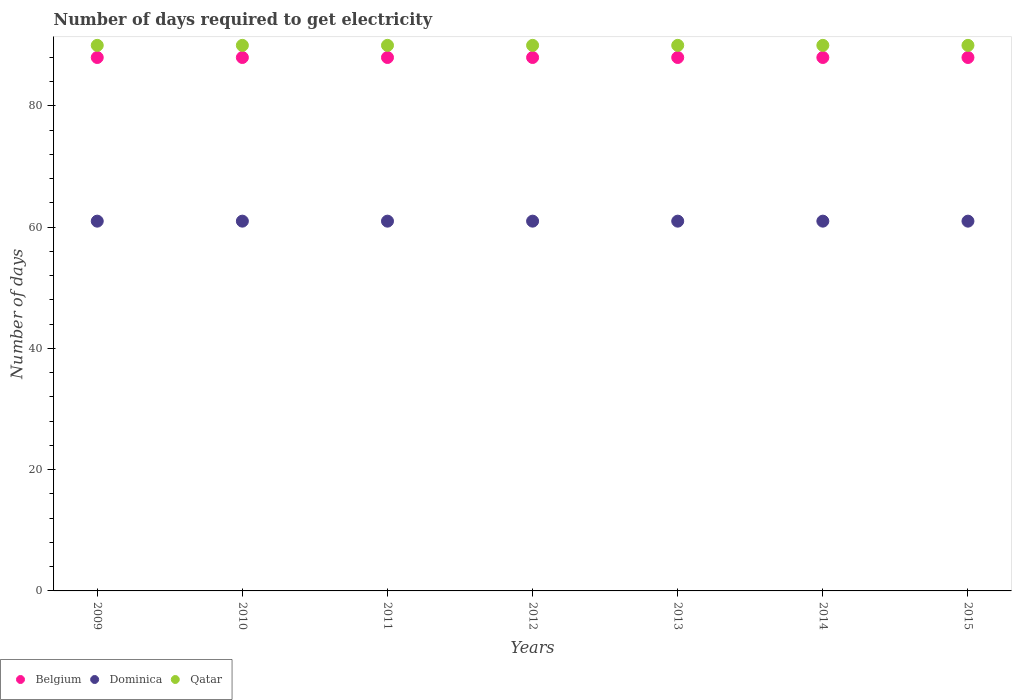How many different coloured dotlines are there?
Provide a short and direct response. 3. Is the number of dotlines equal to the number of legend labels?
Make the answer very short. Yes. What is the number of days required to get electricity in in Qatar in 2010?
Your answer should be compact. 90. Across all years, what is the maximum number of days required to get electricity in in Dominica?
Ensure brevity in your answer.  61. Across all years, what is the minimum number of days required to get electricity in in Qatar?
Keep it short and to the point. 90. In which year was the number of days required to get electricity in in Dominica maximum?
Offer a terse response. 2009. What is the total number of days required to get electricity in in Qatar in the graph?
Your answer should be compact. 630. What is the difference between the number of days required to get electricity in in Dominica in 2011 and that in 2015?
Provide a succinct answer. 0. What is the difference between the number of days required to get electricity in in Dominica in 2011 and the number of days required to get electricity in in Belgium in 2012?
Make the answer very short. -27. What is the average number of days required to get electricity in in Dominica per year?
Make the answer very short. 61. In the year 2009, what is the difference between the number of days required to get electricity in in Dominica and number of days required to get electricity in in Belgium?
Offer a terse response. -27. What is the ratio of the number of days required to get electricity in in Belgium in 2010 to that in 2015?
Offer a terse response. 1. Is the number of days required to get electricity in in Belgium in 2011 less than that in 2015?
Your response must be concise. No. Is the difference between the number of days required to get electricity in in Dominica in 2009 and 2013 greater than the difference between the number of days required to get electricity in in Belgium in 2009 and 2013?
Your answer should be very brief. No. What is the difference between the highest and the second highest number of days required to get electricity in in Belgium?
Your answer should be very brief. 0. What is the difference between the highest and the lowest number of days required to get electricity in in Qatar?
Offer a terse response. 0. In how many years, is the number of days required to get electricity in in Dominica greater than the average number of days required to get electricity in in Dominica taken over all years?
Offer a very short reply. 0. Is the sum of the number of days required to get electricity in in Qatar in 2010 and 2011 greater than the maximum number of days required to get electricity in in Belgium across all years?
Provide a succinct answer. Yes. How many dotlines are there?
Your answer should be very brief. 3. How many years are there in the graph?
Keep it short and to the point. 7. Does the graph contain any zero values?
Offer a terse response. No. What is the title of the graph?
Your answer should be compact. Number of days required to get electricity. Does "Ukraine" appear as one of the legend labels in the graph?
Provide a succinct answer. No. What is the label or title of the Y-axis?
Provide a short and direct response. Number of days. What is the Number of days in Qatar in 2010?
Ensure brevity in your answer.  90. What is the Number of days in Dominica in 2011?
Provide a succinct answer. 61. What is the Number of days in Qatar in 2011?
Make the answer very short. 90. What is the Number of days in Qatar in 2013?
Your answer should be very brief. 90. What is the Number of days of Belgium in 2015?
Provide a short and direct response. 88. What is the Number of days in Dominica in 2015?
Give a very brief answer. 61. Across all years, what is the maximum Number of days in Belgium?
Make the answer very short. 88. Across all years, what is the maximum Number of days in Dominica?
Your answer should be compact. 61. Across all years, what is the minimum Number of days in Belgium?
Give a very brief answer. 88. What is the total Number of days of Belgium in the graph?
Provide a succinct answer. 616. What is the total Number of days of Dominica in the graph?
Give a very brief answer. 427. What is the total Number of days of Qatar in the graph?
Make the answer very short. 630. What is the difference between the Number of days of Qatar in 2009 and that in 2010?
Offer a terse response. 0. What is the difference between the Number of days of Dominica in 2009 and that in 2011?
Offer a terse response. 0. What is the difference between the Number of days of Qatar in 2009 and that in 2011?
Offer a very short reply. 0. What is the difference between the Number of days of Dominica in 2009 and that in 2013?
Provide a succinct answer. 0. What is the difference between the Number of days of Qatar in 2009 and that in 2013?
Give a very brief answer. 0. What is the difference between the Number of days of Dominica in 2009 and that in 2014?
Make the answer very short. 0. What is the difference between the Number of days in Qatar in 2009 and that in 2014?
Your answer should be compact. 0. What is the difference between the Number of days in Belgium in 2009 and that in 2015?
Ensure brevity in your answer.  0. What is the difference between the Number of days of Dominica in 2009 and that in 2015?
Make the answer very short. 0. What is the difference between the Number of days in Dominica in 2010 and that in 2011?
Provide a succinct answer. 0. What is the difference between the Number of days of Belgium in 2010 and that in 2012?
Keep it short and to the point. 0. What is the difference between the Number of days in Dominica in 2010 and that in 2012?
Ensure brevity in your answer.  0. What is the difference between the Number of days of Qatar in 2010 and that in 2012?
Your answer should be very brief. 0. What is the difference between the Number of days of Qatar in 2010 and that in 2013?
Give a very brief answer. 0. What is the difference between the Number of days of Dominica in 2010 and that in 2014?
Your answer should be very brief. 0. What is the difference between the Number of days of Belgium in 2010 and that in 2015?
Your answer should be compact. 0. What is the difference between the Number of days of Dominica in 2011 and that in 2012?
Your response must be concise. 0. What is the difference between the Number of days in Belgium in 2011 and that in 2014?
Provide a succinct answer. 0. What is the difference between the Number of days of Dominica in 2011 and that in 2014?
Your answer should be compact. 0. What is the difference between the Number of days of Dominica in 2011 and that in 2015?
Offer a terse response. 0. What is the difference between the Number of days in Belgium in 2012 and that in 2013?
Provide a succinct answer. 0. What is the difference between the Number of days of Belgium in 2012 and that in 2015?
Offer a terse response. 0. What is the difference between the Number of days of Qatar in 2012 and that in 2015?
Offer a very short reply. 0. What is the difference between the Number of days in Qatar in 2013 and that in 2014?
Offer a very short reply. 0. What is the difference between the Number of days of Dominica in 2013 and that in 2015?
Your answer should be very brief. 0. What is the difference between the Number of days of Belgium in 2014 and that in 2015?
Provide a short and direct response. 0. What is the difference between the Number of days in Belgium in 2009 and the Number of days in Dominica in 2011?
Offer a terse response. 27. What is the difference between the Number of days in Dominica in 2009 and the Number of days in Qatar in 2011?
Ensure brevity in your answer.  -29. What is the difference between the Number of days in Belgium in 2009 and the Number of days in Qatar in 2012?
Give a very brief answer. -2. What is the difference between the Number of days of Belgium in 2009 and the Number of days of Qatar in 2013?
Keep it short and to the point. -2. What is the difference between the Number of days in Dominica in 2009 and the Number of days in Qatar in 2013?
Provide a short and direct response. -29. What is the difference between the Number of days in Belgium in 2009 and the Number of days in Dominica in 2014?
Keep it short and to the point. 27. What is the difference between the Number of days of Dominica in 2009 and the Number of days of Qatar in 2014?
Ensure brevity in your answer.  -29. What is the difference between the Number of days of Belgium in 2009 and the Number of days of Qatar in 2015?
Your answer should be compact. -2. What is the difference between the Number of days in Dominica in 2010 and the Number of days in Qatar in 2012?
Offer a very short reply. -29. What is the difference between the Number of days in Belgium in 2010 and the Number of days in Dominica in 2013?
Offer a very short reply. 27. What is the difference between the Number of days of Belgium in 2010 and the Number of days of Qatar in 2013?
Your answer should be very brief. -2. What is the difference between the Number of days in Belgium in 2010 and the Number of days in Dominica in 2014?
Ensure brevity in your answer.  27. What is the difference between the Number of days in Belgium in 2010 and the Number of days in Dominica in 2015?
Provide a short and direct response. 27. What is the difference between the Number of days of Dominica in 2010 and the Number of days of Qatar in 2015?
Make the answer very short. -29. What is the difference between the Number of days in Dominica in 2011 and the Number of days in Qatar in 2012?
Your response must be concise. -29. What is the difference between the Number of days in Belgium in 2011 and the Number of days in Dominica in 2013?
Your answer should be very brief. 27. What is the difference between the Number of days of Belgium in 2011 and the Number of days of Dominica in 2014?
Keep it short and to the point. 27. What is the difference between the Number of days of Belgium in 2011 and the Number of days of Dominica in 2015?
Give a very brief answer. 27. What is the difference between the Number of days in Belgium in 2011 and the Number of days in Qatar in 2015?
Your answer should be very brief. -2. What is the difference between the Number of days of Dominica in 2011 and the Number of days of Qatar in 2015?
Your answer should be compact. -29. What is the difference between the Number of days in Belgium in 2012 and the Number of days in Dominica in 2013?
Provide a succinct answer. 27. What is the difference between the Number of days of Belgium in 2012 and the Number of days of Qatar in 2013?
Make the answer very short. -2. What is the difference between the Number of days in Dominica in 2012 and the Number of days in Qatar in 2013?
Ensure brevity in your answer.  -29. What is the difference between the Number of days of Belgium in 2012 and the Number of days of Dominica in 2014?
Keep it short and to the point. 27. What is the difference between the Number of days of Belgium in 2012 and the Number of days of Qatar in 2015?
Your answer should be compact. -2. What is the difference between the Number of days of Dominica in 2012 and the Number of days of Qatar in 2015?
Your response must be concise. -29. What is the difference between the Number of days in Belgium in 2013 and the Number of days in Qatar in 2014?
Provide a succinct answer. -2. What is the difference between the Number of days of Belgium in 2013 and the Number of days of Qatar in 2015?
Offer a very short reply. -2. What is the difference between the Number of days in Belgium in 2014 and the Number of days in Dominica in 2015?
Make the answer very short. 27. What is the difference between the Number of days in Belgium in 2014 and the Number of days in Qatar in 2015?
Make the answer very short. -2. What is the average Number of days in Belgium per year?
Offer a very short reply. 88. What is the average Number of days in Qatar per year?
Provide a short and direct response. 90. In the year 2009, what is the difference between the Number of days of Belgium and Number of days of Dominica?
Offer a terse response. 27. In the year 2010, what is the difference between the Number of days of Belgium and Number of days of Dominica?
Provide a short and direct response. 27. In the year 2011, what is the difference between the Number of days of Belgium and Number of days of Dominica?
Provide a succinct answer. 27. In the year 2011, what is the difference between the Number of days in Dominica and Number of days in Qatar?
Your answer should be very brief. -29. In the year 2013, what is the difference between the Number of days in Belgium and Number of days in Dominica?
Your answer should be very brief. 27. In the year 2013, what is the difference between the Number of days in Belgium and Number of days in Qatar?
Your answer should be compact. -2. In the year 2013, what is the difference between the Number of days of Dominica and Number of days of Qatar?
Offer a terse response. -29. In the year 2014, what is the difference between the Number of days of Belgium and Number of days of Dominica?
Provide a succinct answer. 27. In the year 2014, what is the difference between the Number of days in Belgium and Number of days in Qatar?
Your answer should be compact. -2. In the year 2015, what is the difference between the Number of days of Belgium and Number of days of Dominica?
Keep it short and to the point. 27. What is the ratio of the Number of days of Dominica in 2009 to that in 2010?
Make the answer very short. 1. What is the ratio of the Number of days of Qatar in 2009 to that in 2010?
Give a very brief answer. 1. What is the ratio of the Number of days of Belgium in 2009 to that in 2011?
Provide a succinct answer. 1. What is the ratio of the Number of days of Dominica in 2009 to that in 2011?
Provide a succinct answer. 1. What is the ratio of the Number of days of Belgium in 2009 to that in 2012?
Keep it short and to the point. 1. What is the ratio of the Number of days of Qatar in 2009 to that in 2012?
Your answer should be compact. 1. What is the ratio of the Number of days of Belgium in 2009 to that in 2014?
Offer a very short reply. 1. What is the ratio of the Number of days of Qatar in 2009 to that in 2014?
Keep it short and to the point. 1. What is the ratio of the Number of days in Belgium in 2010 to that in 2011?
Ensure brevity in your answer.  1. What is the ratio of the Number of days in Dominica in 2010 to that in 2011?
Ensure brevity in your answer.  1. What is the ratio of the Number of days of Qatar in 2010 to that in 2011?
Provide a short and direct response. 1. What is the ratio of the Number of days in Belgium in 2010 to that in 2012?
Provide a short and direct response. 1. What is the ratio of the Number of days of Qatar in 2010 to that in 2012?
Make the answer very short. 1. What is the ratio of the Number of days of Belgium in 2010 to that in 2013?
Make the answer very short. 1. What is the ratio of the Number of days in Qatar in 2010 to that in 2014?
Your answer should be very brief. 1. What is the ratio of the Number of days in Belgium in 2010 to that in 2015?
Your response must be concise. 1. What is the ratio of the Number of days in Belgium in 2011 to that in 2013?
Keep it short and to the point. 1. What is the ratio of the Number of days of Qatar in 2011 to that in 2013?
Provide a succinct answer. 1. What is the ratio of the Number of days of Belgium in 2011 to that in 2014?
Your answer should be very brief. 1. What is the ratio of the Number of days of Dominica in 2011 to that in 2014?
Provide a short and direct response. 1. What is the ratio of the Number of days in Qatar in 2011 to that in 2015?
Provide a succinct answer. 1. What is the ratio of the Number of days in Belgium in 2012 to that in 2014?
Provide a succinct answer. 1. What is the ratio of the Number of days of Qatar in 2012 to that in 2014?
Make the answer very short. 1. What is the ratio of the Number of days of Dominica in 2012 to that in 2015?
Keep it short and to the point. 1. What is the ratio of the Number of days in Belgium in 2013 to that in 2014?
Give a very brief answer. 1. What is the ratio of the Number of days of Dominica in 2013 to that in 2014?
Your answer should be compact. 1. What is the ratio of the Number of days of Qatar in 2013 to that in 2014?
Keep it short and to the point. 1. What is the ratio of the Number of days in Belgium in 2013 to that in 2015?
Make the answer very short. 1. What is the ratio of the Number of days of Qatar in 2013 to that in 2015?
Your answer should be compact. 1. What is the ratio of the Number of days of Belgium in 2014 to that in 2015?
Keep it short and to the point. 1. What is the difference between the highest and the second highest Number of days in Belgium?
Give a very brief answer. 0. What is the difference between the highest and the second highest Number of days in Dominica?
Provide a short and direct response. 0. What is the difference between the highest and the lowest Number of days of Dominica?
Keep it short and to the point. 0. 